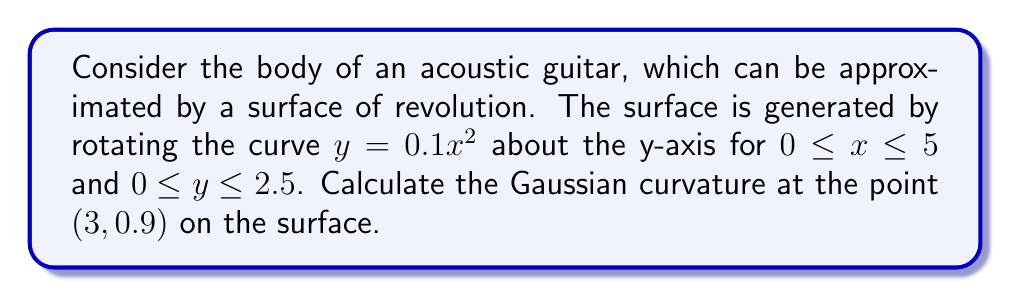Help me with this question. To calculate the Gaussian curvature of a surface of revolution, we'll follow these steps:

1) For a surface of revolution generated by rotating $y = f(x)$ about the y-axis, the Gaussian curvature K is given by:

   $$K = -\frac{f''(x)}{f(x)[1 + (f'(x))^2]}$$

2) In our case, $f(x) = 0.1x^2$. Let's calculate $f'(x)$ and $f''(x)$:

   $f'(x) = 0.2x$
   $f''(x) = 0.2$

3) Now, let's substitute these into our formula for K:

   $$K = -\frac{0.2}{0.1x^2[1 + (0.2x)^2]}$$

4) We need to calculate this at the point (3, 0.9). Note that $x = 3$ and $y = 0.9$.

5) Substituting $x = 3$:

   $$K = -\frac{0.2}{0.1(3)^2[1 + (0.2(3))^2]}$$

6) Simplify:

   $$K = -\frac{0.2}{0.9[1 + 0.36]}$$
   $$K = -\frac{0.2}{0.9(1.36)}$$
   $$K = -\frac{0.2}{1.224}$$
   $$K = -0.1634$$

7) Therefore, the Gaussian curvature at the point (3, 0.9) is approximately -0.1634.
Answer: $-0.1634$ 